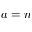Convert formula to latex. <formula><loc_0><loc_0><loc_500><loc_500>a = n</formula> 